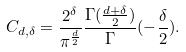<formula> <loc_0><loc_0><loc_500><loc_500>C _ { d , \delta } = \frac { 2 ^ { \delta } } { \pi ^ { \frac { d } { 2 } } } \frac { \Gamma ( \frac { d + \delta } { 2 } ) } \Gamma ( - \frac { \delta } { 2 } ) .</formula> 